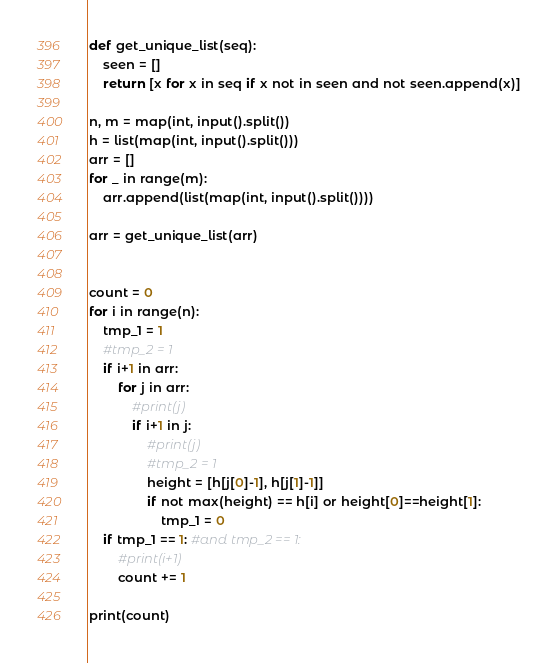<code> <loc_0><loc_0><loc_500><loc_500><_Python_>def get_unique_list(seq):
    seen = []
    return [x for x in seq if x not in seen and not seen.append(x)]

n, m = map(int, input().split())
h = list(map(int, input().split()))
arr = []
for _ in range(m):
    arr.append(list(map(int, input().split())))

arr = get_unique_list(arr)


count = 0
for i in range(n):
    tmp_1 = 1
    #tmp_2 = 1
    if i+1 in arr:
        for j in arr:
            #print(j)
            if i+1 in j:
                #print(j)
                #tmp_2 = 1
                height = [h[j[0]-1], h[j[1]-1]]
                if not max(height) == h[i] or height[0]==height[1]:
                    tmp_1 = 0
    if tmp_1 == 1: #and tmp_2 == 1:
        #print(i+1)
        count += 1

print(count)</code> 